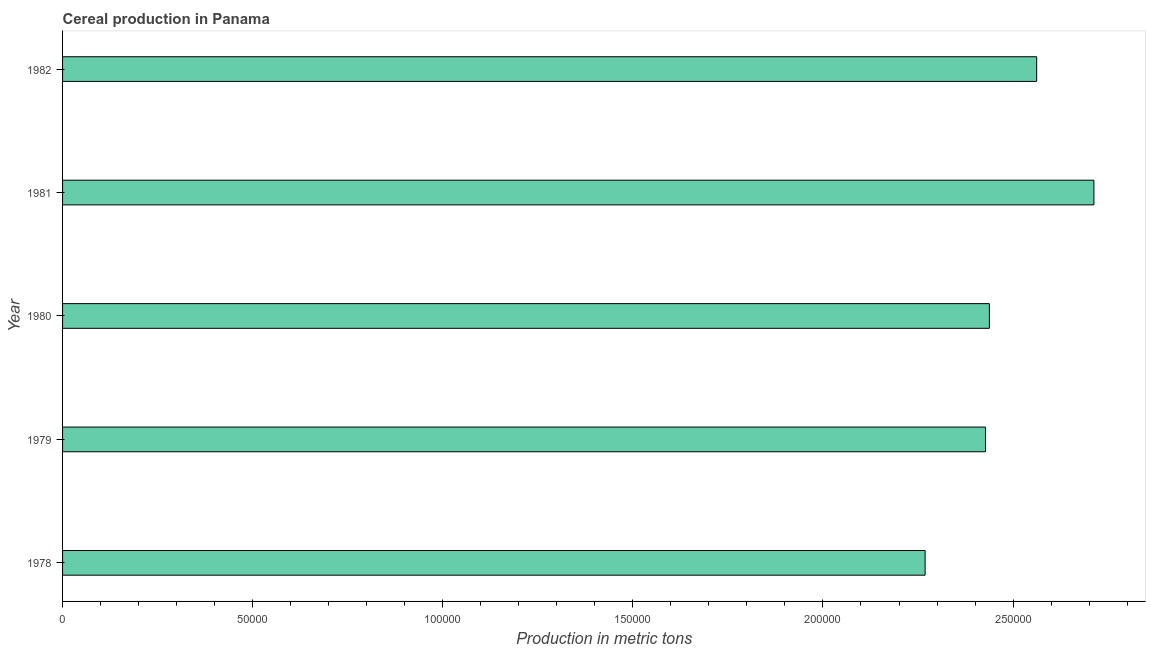What is the title of the graph?
Offer a very short reply. Cereal production in Panama. What is the label or title of the X-axis?
Your answer should be very brief. Production in metric tons. What is the label or title of the Y-axis?
Your answer should be compact. Year. What is the cereal production in 1980?
Give a very brief answer. 2.44e+05. Across all years, what is the maximum cereal production?
Your response must be concise. 2.71e+05. Across all years, what is the minimum cereal production?
Your answer should be compact. 2.27e+05. In which year was the cereal production maximum?
Ensure brevity in your answer.  1981. In which year was the cereal production minimum?
Offer a terse response. 1978. What is the sum of the cereal production?
Provide a short and direct response. 1.24e+06. What is the difference between the cereal production in 1980 and 1981?
Your answer should be compact. -2.75e+04. What is the average cereal production per year?
Give a very brief answer. 2.48e+05. What is the median cereal production?
Your response must be concise. 2.44e+05. In how many years, is the cereal production greater than 100000 metric tons?
Your answer should be compact. 5. What is the ratio of the cereal production in 1979 to that in 1982?
Give a very brief answer. 0.95. Is the difference between the cereal production in 1979 and 1981 greater than the difference between any two years?
Your answer should be compact. No. What is the difference between the highest and the second highest cereal production?
Your response must be concise. 1.51e+04. Is the sum of the cereal production in 1980 and 1981 greater than the maximum cereal production across all years?
Provide a short and direct response. Yes. What is the difference between the highest and the lowest cereal production?
Give a very brief answer. 4.44e+04. In how many years, is the cereal production greater than the average cereal production taken over all years?
Keep it short and to the point. 2. How many bars are there?
Give a very brief answer. 5. How many years are there in the graph?
Your answer should be very brief. 5. What is the difference between two consecutive major ticks on the X-axis?
Keep it short and to the point. 5.00e+04. What is the Production in metric tons in 1978?
Your response must be concise. 2.27e+05. What is the Production in metric tons in 1979?
Your answer should be very brief. 2.43e+05. What is the Production in metric tons of 1980?
Keep it short and to the point. 2.44e+05. What is the Production in metric tons in 1981?
Give a very brief answer. 2.71e+05. What is the Production in metric tons in 1982?
Keep it short and to the point. 2.56e+05. What is the difference between the Production in metric tons in 1978 and 1979?
Give a very brief answer. -1.59e+04. What is the difference between the Production in metric tons in 1978 and 1980?
Give a very brief answer. -1.69e+04. What is the difference between the Production in metric tons in 1978 and 1981?
Make the answer very short. -4.44e+04. What is the difference between the Production in metric tons in 1978 and 1982?
Ensure brevity in your answer.  -2.93e+04. What is the difference between the Production in metric tons in 1979 and 1980?
Offer a very short reply. -1010. What is the difference between the Production in metric tons in 1979 and 1981?
Your answer should be very brief. -2.85e+04. What is the difference between the Production in metric tons in 1979 and 1982?
Provide a short and direct response. -1.35e+04. What is the difference between the Production in metric tons in 1980 and 1981?
Offer a terse response. -2.75e+04. What is the difference between the Production in metric tons in 1980 and 1982?
Provide a short and direct response. -1.24e+04. What is the difference between the Production in metric tons in 1981 and 1982?
Offer a very short reply. 1.51e+04. What is the ratio of the Production in metric tons in 1978 to that in 1979?
Your response must be concise. 0.94. What is the ratio of the Production in metric tons in 1978 to that in 1980?
Give a very brief answer. 0.93. What is the ratio of the Production in metric tons in 1978 to that in 1981?
Your answer should be very brief. 0.84. What is the ratio of the Production in metric tons in 1978 to that in 1982?
Your answer should be compact. 0.89. What is the ratio of the Production in metric tons in 1979 to that in 1980?
Provide a short and direct response. 1. What is the ratio of the Production in metric tons in 1979 to that in 1981?
Ensure brevity in your answer.  0.9. What is the ratio of the Production in metric tons in 1979 to that in 1982?
Provide a succinct answer. 0.95. What is the ratio of the Production in metric tons in 1980 to that in 1981?
Provide a succinct answer. 0.9. What is the ratio of the Production in metric tons in 1980 to that in 1982?
Ensure brevity in your answer.  0.95. What is the ratio of the Production in metric tons in 1981 to that in 1982?
Make the answer very short. 1.06. 